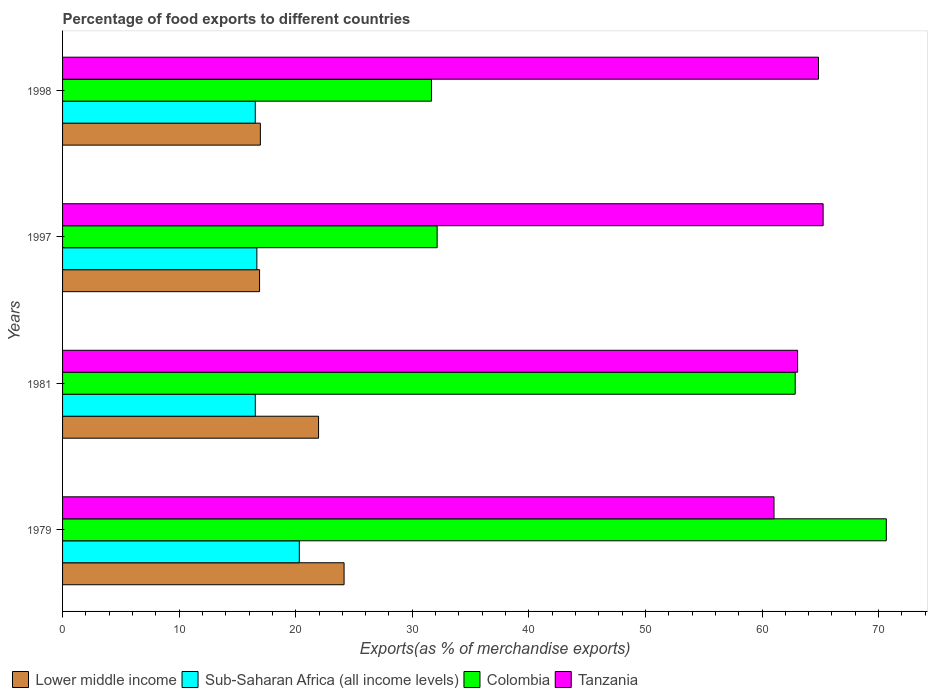How many different coloured bars are there?
Provide a short and direct response. 4. Are the number of bars on each tick of the Y-axis equal?
Provide a short and direct response. Yes. How many bars are there on the 2nd tick from the top?
Provide a succinct answer. 4. What is the label of the 4th group of bars from the top?
Ensure brevity in your answer.  1979. In how many cases, is the number of bars for a given year not equal to the number of legend labels?
Your answer should be very brief. 0. What is the percentage of exports to different countries in Lower middle income in 1979?
Keep it short and to the point. 24.15. Across all years, what is the maximum percentage of exports to different countries in Lower middle income?
Ensure brevity in your answer.  24.15. Across all years, what is the minimum percentage of exports to different countries in Colombia?
Your answer should be very brief. 31.65. In which year was the percentage of exports to different countries in Colombia maximum?
Your answer should be very brief. 1979. In which year was the percentage of exports to different countries in Colombia minimum?
Make the answer very short. 1998. What is the total percentage of exports to different countries in Tanzania in the graph?
Your answer should be compact. 254.17. What is the difference between the percentage of exports to different countries in Lower middle income in 1997 and that in 1998?
Your answer should be compact. -0.07. What is the difference between the percentage of exports to different countries in Tanzania in 1981 and the percentage of exports to different countries in Lower middle income in 1998?
Your answer should be compact. 46.09. What is the average percentage of exports to different countries in Tanzania per year?
Provide a succinct answer. 63.54. In the year 1997, what is the difference between the percentage of exports to different countries in Lower middle income and percentage of exports to different countries in Sub-Saharan Africa (all income levels)?
Your response must be concise. 0.23. In how many years, is the percentage of exports to different countries in Colombia greater than 16 %?
Make the answer very short. 4. What is the ratio of the percentage of exports to different countries in Tanzania in 1979 to that in 1981?
Keep it short and to the point. 0.97. Is the difference between the percentage of exports to different countries in Lower middle income in 1981 and 1998 greater than the difference between the percentage of exports to different countries in Sub-Saharan Africa (all income levels) in 1981 and 1998?
Provide a short and direct response. Yes. What is the difference between the highest and the second highest percentage of exports to different countries in Tanzania?
Ensure brevity in your answer.  0.4. What is the difference between the highest and the lowest percentage of exports to different countries in Colombia?
Your answer should be very brief. 39.01. Is the sum of the percentage of exports to different countries in Sub-Saharan Africa (all income levels) in 1979 and 1998 greater than the maximum percentage of exports to different countries in Colombia across all years?
Provide a succinct answer. No. Is it the case that in every year, the sum of the percentage of exports to different countries in Colombia and percentage of exports to different countries in Sub-Saharan Africa (all income levels) is greater than the sum of percentage of exports to different countries in Tanzania and percentage of exports to different countries in Lower middle income?
Offer a very short reply. Yes. What does the 2nd bar from the top in 1998 represents?
Provide a short and direct response. Colombia. What does the 2nd bar from the bottom in 1998 represents?
Provide a succinct answer. Sub-Saharan Africa (all income levels). How many bars are there?
Offer a very short reply. 16. Are the values on the major ticks of X-axis written in scientific E-notation?
Make the answer very short. No. Does the graph contain any zero values?
Provide a short and direct response. No. How many legend labels are there?
Offer a very short reply. 4. What is the title of the graph?
Keep it short and to the point. Percentage of food exports to different countries. What is the label or title of the X-axis?
Your answer should be very brief. Exports(as % of merchandise exports). What is the Exports(as % of merchandise exports) in Lower middle income in 1979?
Your response must be concise. 24.15. What is the Exports(as % of merchandise exports) of Sub-Saharan Africa (all income levels) in 1979?
Your answer should be very brief. 20.31. What is the Exports(as % of merchandise exports) of Colombia in 1979?
Your response must be concise. 70.66. What is the Exports(as % of merchandise exports) of Tanzania in 1979?
Provide a short and direct response. 61.03. What is the Exports(as % of merchandise exports) in Lower middle income in 1981?
Give a very brief answer. 21.96. What is the Exports(as % of merchandise exports) in Sub-Saharan Africa (all income levels) in 1981?
Your answer should be very brief. 16.53. What is the Exports(as % of merchandise exports) of Colombia in 1981?
Give a very brief answer. 62.85. What is the Exports(as % of merchandise exports) of Tanzania in 1981?
Provide a short and direct response. 63.05. What is the Exports(as % of merchandise exports) of Lower middle income in 1997?
Keep it short and to the point. 16.9. What is the Exports(as % of merchandise exports) of Sub-Saharan Africa (all income levels) in 1997?
Offer a very short reply. 16.67. What is the Exports(as % of merchandise exports) in Colombia in 1997?
Offer a very short reply. 32.13. What is the Exports(as % of merchandise exports) in Tanzania in 1997?
Offer a very short reply. 65.24. What is the Exports(as % of merchandise exports) of Lower middle income in 1998?
Provide a short and direct response. 16.97. What is the Exports(as % of merchandise exports) in Sub-Saharan Africa (all income levels) in 1998?
Offer a very short reply. 16.53. What is the Exports(as % of merchandise exports) of Colombia in 1998?
Your answer should be very brief. 31.65. What is the Exports(as % of merchandise exports) in Tanzania in 1998?
Your response must be concise. 64.85. Across all years, what is the maximum Exports(as % of merchandise exports) in Lower middle income?
Make the answer very short. 24.15. Across all years, what is the maximum Exports(as % of merchandise exports) in Sub-Saharan Africa (all income levels)?
Offer a terse response. 20.31. Across all years, what is the maximum Exports(as % of merchandise exports) in Colombia?
Provide a short and direct response. 70.66. Across all years, what is the maximum Exports(as % of merchandise exports) in Tanzania?
Give a very brief answer. 65.24. Across all years, what is the minimum Exports(as % of merchandise exports) of Lower middle income?
Give a very brief answer. 16.9. Across all years, what is the minimum Exports(as % of merchandise exports) of Sub-Saharan Africa (all income levels)?
Give a very brief answer. 16.53. Across all years, what is the minimum Exports(as % of merchandise exports) of Colombia?
Ensure brevity in your answer.  31.65. Across all years, what is the minimum Exports(as % of merchandise exports) in Tanzania?
Provide a short and direct response. 61.03. What is the total Exports(as % of merchandise exports) in Lower middle income in the graph?
Offer a very short reply. 79.97. What is the total Exports(as % of merchandise exports) in Sub-Saharan Africa (all income levels) in the graph?
Your answer should be compact. 70.04. What is the total Exports(as % of merchandise exports) of Colombia in the graph?
Give a very brief answer. 197.29. What is the total Exports(as % of merchandise exports) in Tanzania in the graph?
Ensure brevity in your answer.  254.17. What is the difference between the Exports(as % of merchandise exports) in Lower middle income in 1979 and that in 1981?
Your answer should be compact. 2.19. What is the difference between the Exports(as % of merchandise exports) in Sub-Saharan Africa (all income levels) in 1979 and that in 1981?
Ensure brevity in your answer.  3.78. What is the difference between the Exports(as % of merchandise exports) of Colombia in 1979 and that in 1981?
Offer a terse response. 7.81. What is the difference between the Exports(as % of merchandise exports) of Tanzania in 1979 and that in 1981?
Your answer should be very brief. -2.02. What is the difference between the Exports(as % of merchandise exports) in Lower middle income in 1979 and that in 1997?
Ensure brevity in your answer.  7.25. What is the difference between the Exports(as % of merchandise exports) of Sub-Saharan Africa (all income levels) in 1979 and that in 1997?
Keep it short and to the point. 3.64. What is the difference between the Exports(as % of merchandise exports) of Colombia in 1979 and that in 1997?
Ensure brevity in your answer.  38.53. What is the difference between the Exports(as % of merchandise exports) of Tanzania in 1979 and that in 1997?
Offer a terse response. -4.21. What is the difference between the Exports(as % of merchandise exports) in Lower middle income in 1979 and that in 1998?
Your response must be concise. 7.18. What is the difference between the Exports(as % of merchandise exports) of Sub-Saharan Africa (all income levels) in 1979 and that in 1998?
Provide a short and direct response. 3.78. What is the difference between the Exports(as % of merchandise exports) of Colombia in 1979 and that in 1998?
Your response must be concise. 39.01. What is the difference between the Exports(as % of merchandise exports) in Tanzania in 1979 and that in 1998?
Make the answer very short. -3.82. What is the difference between the Exports(as % of merchandise exports) in Lower middle income in 1981 and that in 1997?
Provide a succinct answer. 5.06. What is the difference between the Exports(as % of merchandise exports) of Sub-Saharan Africa (all income levels) in 1981 and that in 1997?
Provide a short and direct response. -0.13. What is the difference between the Exports(as % of merchandise exports) of Colombia in 1981 and that in 1997?
Ensure brevity in your answer.  30.72. What is the difference between the Exports(as % of merchandise exports) in Tanzania in 1981 and that in 1997?
Provide a succinct answer. -2.19. What is the difference between the Exports(as % of merchandise exports) in Lower middle income in 1981 and that in 1998?
Give a very brief answer. 4.99. What is the difference between the Exports(as % of merchandise exports) in Sub-Saharan Africa (all income levels) in 1981 and that in 1998?
Offer a terse response. 0. What is the difference between the Exports(as % of merchandise exports) in Colombia in 1981 and that in 1998?
Keep it short and to the point. 31.2. What is the difference between the Exports(as % of merchandise exports) of Tanzania in 1981 and that in 1998?
Provide a succinct answer. -1.79. What is the difference between the Exports(as % of merchandise exports) in Lower middle income in 1997 and that in 1998?
Offer a very short reply. -0.07. What is the difference between the Exports(as % of merchandise exports) of Sub-Saharan Africa (all income levels) in 1997 and that in 1998?
Provide a succinct answer. 0.14. What is the difference between the Exports(as % of merchandise exports) in Colombia in 1997 and that in 1998?
Your response must be concise. 0.48. What is the difference between the Exports(as % of merchandise exports) in Tanzania in 1997 and that in 1998?
Your answer should be very brief. 0.4. What is the difference between the Exports(as % of merchandise exports) of Lower middle income in 1979 and the Exports(as % of merchandise exports) of Sub-Saharan Africa (all income levels) in 1981?
Provide a short and direct response. 7.62. What is the difference between the Exports(as % of merchandise exports) of Lower middle income in 1979 and the Exports(as % of merchandise exports) of Colombia in 1981?
Provide a succinct answer. -38.7. What is the difference between the Exports(as % of merchandise exports) of Lower middle income in 1979 and the Exports(as % of merchandise exports) of Tanzania in 1981?
Your answer should be very brief. -38.9. What is the difference between the Exports(as % of merchandise exports) in Sub-Saharan Africa (all income levels) in 1979 and the Exports(as % of merchandise exports) in Colombia in 1981?
Your response must be concise. -42.54. What is the difference between the Exports(as % of merchandise exports) of Sub-Saharan Africa (all income levels) in 1979 and the Exports(as % of merchandise exports) of Tanzania in 1981?
Offer a terse response. -42.74. What is the difference between the Exports(as % of merchandise exports) in Colombia in 1979 and the Exports(as % of merchandise exports) in Tanzania in 1981?
Your answer should be very brief. 7.61. What is the difference between the Exports(as % of merchandise exports) of Lower middle income in 1979 and the Exports(as % of merchandise exports) of Sub-Saharan Africa (all income levels) in 1997?
Your answer should be very brief. 7.48. What is the difference between the Exports(as % of merchandise exports) of Lower middle income in 1979 and the Exports(as % of merchandise exports) of Colombia in 1997?
Ensure brevity in your answer.  -7.98. What is the difference between the Exports(as % of merchandise exports) of Lower middle income in 1979 and the Exports(as % of merchandise exports) of Tanzania in 1997?
Give a very brief answer. -41.09. What is the difference between the Exports(as % of merchandise exports) in Sub-Saharan Africa (all income levels) in 1979 and the Exports(as % of merchandise exports) in Colombia in 1997?
Your answer should be very brief. -11.82. What is the difference between the Exports(as % of merchandise exports) in Sub-Saharan Africa (all income levels) in 1979 and the Exports(as % of merchandise exports) in Tanzania in 1997?
Offer a terse response. -44.93. What is the difference between the Exports(as % of merchandise exports) in Colombia in 1979 and the Exports(as % of merchandise exports) in Tanzania in 1997?
Provide a short and direct response. 5.42. What is the difference between the Exports(as % of merchandise exports) in Lower middle income in 1979 and the Exports(as % of merchandise exports) in Sub-Saharan Africa (all income levels) in 1998?
Give a very brief answer. 7.62. What is the difference between the Exports(as % of merchandise exports) of Lower middle income in 1979 and the Exports(as % of merchandise exports) of Colombia in 1998?
Provide a succinct answer. -7.5. What is the difference between the Exports(as % of merchandise exports) of Lower middle income in 1979 and the Exports(as % of merchandise exports) of Tanzania in 1998?
Give a very brief answer. -40.7. What is the difference between the Exports(as % of merchandise exports) in Sub-Saharan Africa (all income levels) in 1979 and the Exports(as % of merchandise exports) in Colombia in 1998?
Offer a terse response. -11.34. What is the difference between the Exports(as % of merchandise exports) of Sub-Saharan Africa (all income levels) in 1979 and the Exports(as % of merchandise exports) of Tanzania in 1998?
Ensure brevity in your answer.  -44.54. What is the difference between the Exports(as % of merchandise exports) of Colombia in 1979 and the Exports(as % of merchandise exports) of Tanzania in 1998?
Your response must be concise. 5.82. What is the difference between the Exports(as % of merchandise exports) in Lower middle income in 1981 and the Exports(as % of merchandise exports) in Sub-Saharan Africa (all income levels) in 1997?
Provide a short and direct response. 5.29. What is the difference between the Exports(as % of merchandise exports) of Lower middle income in 1981 and the Exports(as % of merchandise exports) of Colombia in 1997?
Give a very brief answer. -10.17. What is the difference between the Exports(as % of merchandise exports) of Lower middle income in 1981 and the Exports(as % of merchandise exports) of Tanzania in 1997?
Make the answer very short. -43.28. What is the difference between the Exports(as % of merchandise exports) in Sub-Saharan Africa (all income levels) in 1981 and the Exports(as % of merchandise exports) in Colombia in 1997?
Your response must be concise. -15.6. What is the difference between the Exports(as % of merchandise exports) of Sub-Saharan Africa (all income levels) in 1981 and the Exports(as % of merchandise exports) of Tanzania in 1997?
Give a very brief answer. -48.71. What is the difference between the Exports(as % of merchandise exports) of Colombia in 1981 and the Exports(as % of merchandise exports) of Tanzania in 1997?
Keep it short and to the point. -2.4. What is the difference between the Exports(as % of merchandise exports) of Lower middle income in 1981 and the Exports(as % of merchandise exports) of Sub-Saharan Africa (all income levels) in 1998?
Make the answer very short. 5.43. What is the difference between the Exports(as % of merchandise exports) in Lower middle income in 1981 and the Exports(as % of merchandise exports) in Colombia in 1998?
Offer a terse response. -9.69. What is the difference between the Exports(as % of merchandise exports) in Lower middle income in 1981 and the Exports(as % of merchandise exports) in Tanzania in 1998?
Keep it short and to the point. -42.89. What is the difference between the Exports(as % of merchandise exports) in Sub-Saharan Africa (all income levels) in 1981 and the Exports(as % of merchandise exports) in Colombia in 1998?
Provide a short and direct response. -15.12. What is the difference between the Exports(as % of merchandise exports) of Sub-Saharan Africa (all income levels) in 1981 and the Exports(as % of merchandise exports) of Tanzania in 1998?
Provide a succinct answer. -48.31. What is the difference between the Exports(as % of merchandise exports) of Colombia in 1981 and the Exports(as % of merchandise exports) of Tanzania in 1998?
Offer a very short reply. -2. What is the difference between the Exports(as % of merchandise exports) in Lower middle income in 1997 and the Exports(as % of merchandise exports) in Sub-Saharan Africa (all income levels) in 1998?
Your answer should be compact. 0.37. What is the difference between the Exports(as % of merchandise exports) in Lower middle income in 1997 and the Exports(as % of merchandise exports) in Colombia in 1998?
Provide a succinct answer. -14.75. What is the difference between the Exports(as % of merchandise exports) of Lower middle income in 1997 and the Exports(as % of merchandise exports) of Tanzania in 1998?
Provide a succinct answer. -47.95. What is the difference between the Exports(as % of merchandise exports) of Sub-Saharan Africa (all income levels) in 1997 and the Exports(as % of merchandise exports) of Colombia in 1998?
Offer a terse response. -14.98. What is the difference between the Exports(as % of merchandise exports) in Sub-Saharan Africa (all income levels) in 1997 and the Exports(as % of merchandise exports) in Tanzania in 1998?
Provide a short and direct response. -48.18. What is the difference between the Exports(as % of merchandise exports) of Colombia in 1997 and the Exports(as % of merchandise exports) of Tanzania in 1998?
Give a very brief answer. -32.71. What is the average Exports(as % of merchandise exports) in Lower middle income per year?
Your answer should be compact. 19.99. What is the average Exports(as % of merchandise exports) of Sub-Saharan Africa (all income levels) per year?
Ensure brevity in your answer.  17.51. What is the average Exports(as % of merchandise exports) of Colombia per year?
Offer a terse response. 49.32. What is the average Exports(as % of merchandise exports) of Tanzania per year?
Keep it short and to the point. 63.54. In the year 1979, what is the difference between the Exports(as % of merchandise exports) of Lower middle income and Exports(as % of merchandise exports) of Sub-Saharan Africa (all income levels)?
Your answer should be compact. 3.84. In the year 1979, what is the difference between the Exports(as % of merchandise exports) of Lower middle income and Exports(as % of merchandise exports) of Colombia?
Give a very brief answer. -46.51. In the year 1979, what is the difference between the Exports(as % of merchandise exports) in Lower middle income and Exports(as % of merchandise exports) in Tanzania?
Keep it short and to the point. -36.88. In the year 1979, what is the difference between the Exports(as % of merchandise exports) of Sub-Saharan Africa (all income levels) and Exports(as % of merchandise exports) of Colombia?
Ensure brevity in your answer.  -50.35. In the year 1979, what is the difference between the Exports(as % of merchandise exports) of Sub-Saharan Africa (all income levels) and Exports(as % of merchandise exports) of Tanzania?
Keep it short and to the point. -40.72. In the year 1979, what is the difference between the Exports(as % of merchandise exports) in Colombia and Exports(as % of merchandise exports) in Tanzania?
Your answer should be compact. 9.63. In the year 1981, what is the difference between the Exports(as % of merchandise exports) in Lower middle income and Exports(as % of merchandise exports) in Sub-Saharan Africa (all income levels)?
Offer a terse response. 5.43. In the year 1981, what is the difference between the Exports(as % of merchandise exports) in Lower middle income and Exports(as % of merchandise exports) in Colombia?
Give a very brief answer. -40.89. In the year 1981, what is the difference between the Exports(as % of merchandise exports) of Lower middle income and Exports(as % of merchandise exports) of Tanzania?
Make the answer very short. -41.09. In the year 1981, what is the difference between the Exports(as % of merchandise exports) in Sub-Saharan Africa (all income levels) and Exports(as % of merchandise exports) in Colombia?
Provide a short and direct response. -46.31. In the year 1981, what is the difference between the Exports(as % of merchandise exports) in Sub-Saharan Africa (all income levels) and Exports(as % of merchandise exports) in Tanzania?
Provide a succinct answer. -46.52. In the year 1981, what is the difference between the Exports(as % of merchandise exports) of Colombia and Exports(as % of merchandise exports) of Tanzania?
Ensure brevity in your answer.  -0.21. In the year 1997, what is the difference between the Exports(as % of merchandise exports) in Lower middle income and Exports(as % of merchandise exports) in Sub-Saharan Africa (all income levels)?
Your response must be concise. 0.23. In the year 1997, what is the difference between the Exports(as % of merchandise exports) of Lower middle income and Exports(as % of merchandise exports) of Colombia?
Offer a very short reply. -15.23. In the year 1997, what is the difference between the Exports(as % of merchandise exports) of Lower middle income and Exports(as % of merchandise exports) of Tanzania?
Your answer should be compact. -48.34. In the year 1997, what is the difference between the Exports(as % of merchandise exports) of Sub-Saharan Africa (all income levels) and Exports(as % of merchandise exports) of Colombia?
Make the answer very short. -15.46. In the year 1997, what is the difference between the Exports(as % of merchandise exports) of Sub-Saharan Africa (all income levels) and Exports(as % of merchandise exports) of Tanzania?
Your response must be concise. -48.58. In the year 1997, what is the difference between the Exports(as % of merchandise exports) in Colombia and Exports(as % of merchandise exports) in Tanzania?
Offer a terse response. -33.11. In the year 1998, what is the difference between the Exports(as % of merchandise exports) of Lower middle income and Exports(as % of merchandise exports) of Sub-Saharan Africa (all income levels)?
Make the answer very short. 0.44. In the year 1998, what is the difference between the Exports(as % of merchandise exports) in Lower middle income and Exports(as % of merchandise exports) in Colombia?
Provide a short and direct response. -14.68. In the year 1998, what is the difference between the Exports(as % of merchandise exports) in Lower middle income and Exports(as % of merchandise exports) in Tanzania?
Your response must be concise. -47.88. In the year 1998, what is the difference between the Exports(as % of merchandise exports) of Sub-Saharan Africa (all income levels) and Exports(as % of merchandise exports) of Colombia?
Your answer should be compact. -15.12. In the year 1998, what is the difference between the Exports(as % of merchandise exports) in Sub-Saharan Africa (all income levels) and Exports(as % of merchandise exports) in Tanzania?
Make the answer very short. -48.31. In the year 1998, what is the difference between the Exports(as % of merchandise exports) in Colombia and Exports(as % of merchandise exports) in Tanzania?
Your response must be concise. -33.2. What is the ratio of the Exports(as % of merchandise exports) in Lower middle income in 1979 to that in 1981?
Make the answer very short. 1.1. What is the ratio of the Exports(as % of merchandise exports) in Sub-Saharan Africa (all income levels) in 1979 to that in 1981?
Offer a very short reply. 1.23. What is the ratio of the Exports(as % of merchandise exports) of Colombia in 1979 to that in 1981?
Offer a terse response. 1.12. What is the ratio of the Exports(as % of merchandise exports) of Tanzania in 1979 to that in 1981?
Give a very brief answer. 0.97. What is the ratio of the Exports(as % of merchandise exports) in Lower middle income in 1979 to that in 1997?
Ensure brevity in your answer.  1.43. What is the ratio of the Exports(as % of merchandise exports) in Sub-Saharan Africa (all income levels) in 1979 to that in 1997?
Keep it short and to the point. 1.22. What is the ratio of the Exports(as % of merchandise exports) in Colombia in 1979 to that in 1997?
Your answer should be very brief. 2.2. What is the ratio of the Exports(as % of merchandise exports) in Tanzania in 1979 to that in 1997?
Your response must be concise. 0.94. What is the ratio of the Exports(as % of merchandise exports) of Lower middle income in 1979 to that in 1998?
Give a very brief answer. 1.42. What is the ratio of the Exports(as % of merchandise exports) in Sub-Saharan Africa (all income levels) in 1979 to that in 1998?
Your response must be concise. 1.23. What is the ratio of the Exports(as % of merchandise exports) of Colombia in 1979 to that in 1998?
Your response must be concise. 2.23. What is the ratio of the Exports(as % of merchandise exports) of Tanzania in 1979 to that in 1998?
Make the answer very short. 0.94. What is the ratio of the Exports(as % of merchandise exports) in Lower middle income in 1981 to that in 1997?
Provide a succinct answer. 1.3. What is the ratio of the Exports(as % of merchandise exports) in Sub-Saharan Africa (all income levels) in 1981 to that in 1997?
Ensure brevity in your answer.  0.99. What is the ratio of the Exports(as % of merchandise exports) of Colombia in 1981 to that in 1997?
Keep it short and to the point. 1.96. What is the ratio of the Exports(as % of merchandise exports) in Tanzania in 1981 to that in 1997?
Give a very brief answer. 0.97. What is the ratio of the Exports(as % of merchandise exports) in Lower middle income in 1981 to that in 1998?
Make the answer very short. 1.29. What is the ratio of the Exports(as % of merchandise exports) in Sub-Saharan Africa (all income levels) in 1981 to that in 1998?
Your answer should be compact. 1. What is the ratio of the Exports(as % of merchandise exports) in Colombia in 1981 to that in 1998?
Your answer should be compact. 1.99. What is the ratio of the Exports(as % of merchandise exports) in Tanzania in 1981 to that in 1998?
Your response must be concise. 0.97. What is the ratio of the Exports(as % of merchandise exports) in Lower middle income in 1997 to that in 1998?
Provide a short and direct response. 1. What is the ratio of the Exports(as % of merchandise exports) in Sub-Saharan Africa (all income levels) in 1997 to that in 1998?
Ensure brevity in your answer.  1.01. What is the ratio of the Exports(as % of merchandise exports) of Colombia in 1997 to that in 1998?
Ensure brevity in your answer.  1.02. What is the difference between the highest and the second highest Exports(as % of merchandise exports) in Lower middle income?
Provide a short and direct response. 2.19. What is the difference between the highest and the second highest Exports(as % of merchandise exports) in Sub-Saharan Africa (all income levels)?
Your answer should be compact. 3.64. What is the difference between the highest and the second highest Exports(as % of merchandise exports) in Colombia?
Your answer should be compact. 7.81. What is the difference between the highest and the second highest Exports(as % of merchandise exports) of Tanzania?
Give a very brief answer. 0.4. What is the difference between the highest and the lowest Exports(as % of merchandise exports) of Lower middle income?
Give a very brief answer. 7.25. What is the difference between the highest and the lowest Exports(as % of merchandise exports) of Sub-Saharan Africa (all income levels)?
Your answer should be very brief. 3.78. What is the difference between the highest and the lowest Exports(as % of merchandise exports) of Colombia?
Offer a terse response. 39.01. What is the difference between the highest and the lowest Exports(as % of merchandise exports) in Tanzania?
Provide a short and direct response. 4.21. 